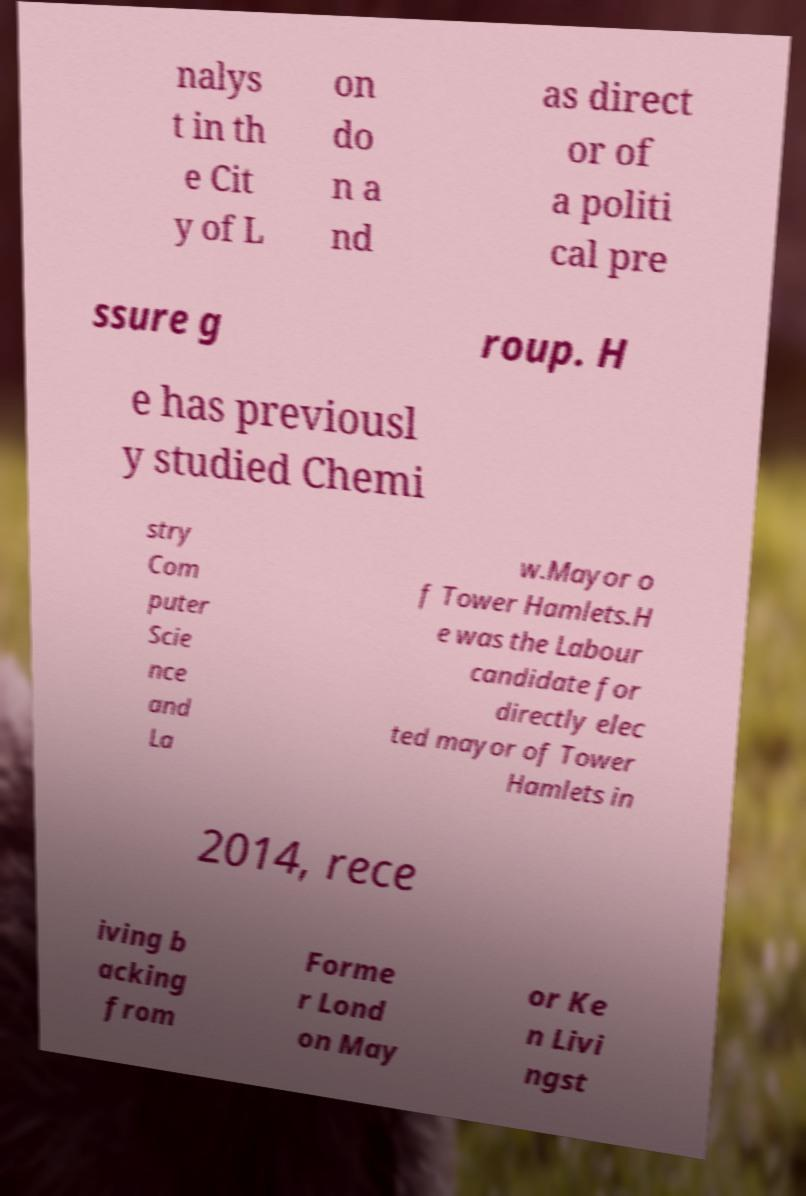Please read and relay the text visible in this image. What does it say? nalys t in th e Cit y of L on do n a nd as direct or of a politi cal pre ssure g roup. H e has previousl y studied Chemi stry Com puter Scie nce and La w.Mayor o f Tower Hamlets.H e was the Labour candidate for directly elec ted mayor of Tower Hamlets in 2014, rece iving b acking from Forme r Lond on May or Ke n Livi ngst 